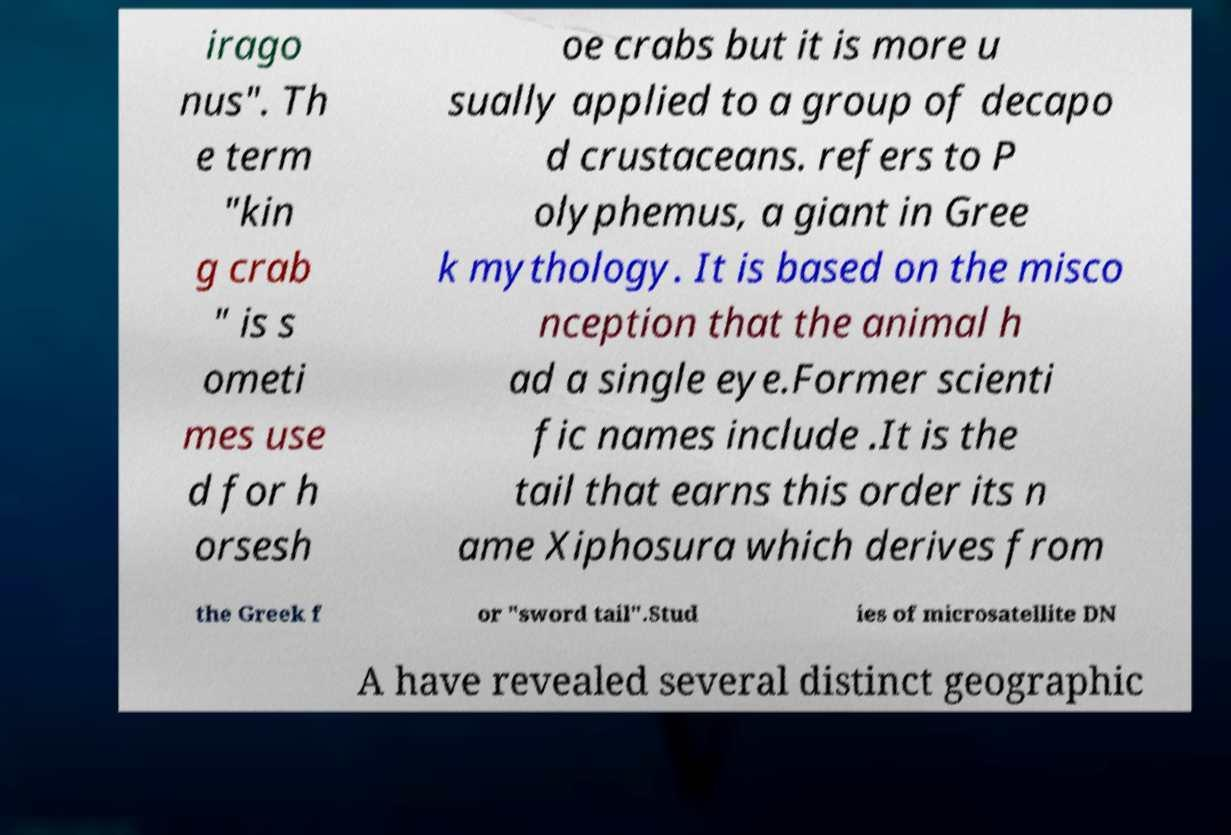What messages or text are displayed in this image? I need them in a readable, typed format. irago nus". Th e term "kin g crab " is s ometi mes use d for h orsesh oe crabs but it is more u sually applied to a group of decapo d crustaceans. refers to P olyphemus, a giant in Gree k mythology. It is based on the misco nception that the animal h ad a single eye.Former scienti fic names include .It is the tail that earns this order its n ame Xiphosura which derives from the Greek f or "sword tail".Stud ies of microsatellite DN A have revealed several distinct geographic 